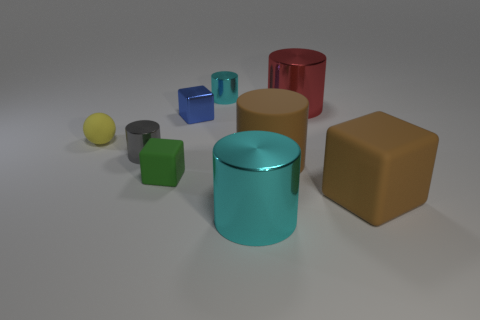Subtract all gray cylinders. How many cylinders are left? 4 Subtract all green cylinders. Subtract all purple blocks. How many cylinders are left? 5 Add 1 large red metallic cylinders. How many objects exist? 10 Subtract all spheres. How many objects are left? 8 Subtract 0 purple blocks. How many objects are left? 9 Subtract all tiny blue cubes. Subtract all green metallic blocks. How many objects are left? 8 Add 4 large red things. How many large red things are left? 5 Add 7 purple rubber cylinders. How many purple rubber cylinders exist? 7 